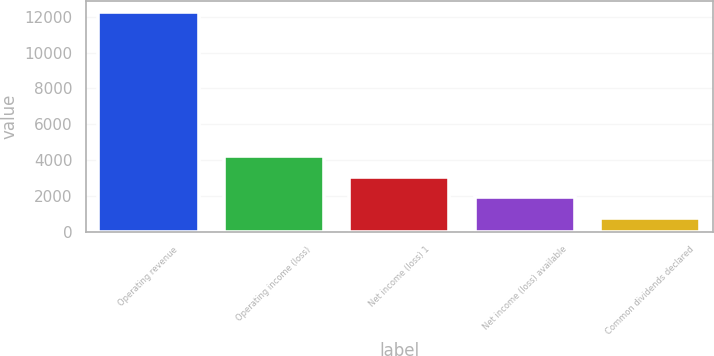Convert chart. <chart><loc_0><loc_0><loc_500><loc_500><bar_chart><fcel>Operating revenue<fcel>Operating income (loss)<fcel>Net income (loss) 1<fcel>Net income (loss) available<fcel>Common dividends declared<nl><fcel>12254<fcel>4225.7<fcel>3078.8<fcel>1931.9<fcel>785<nl></chart> 